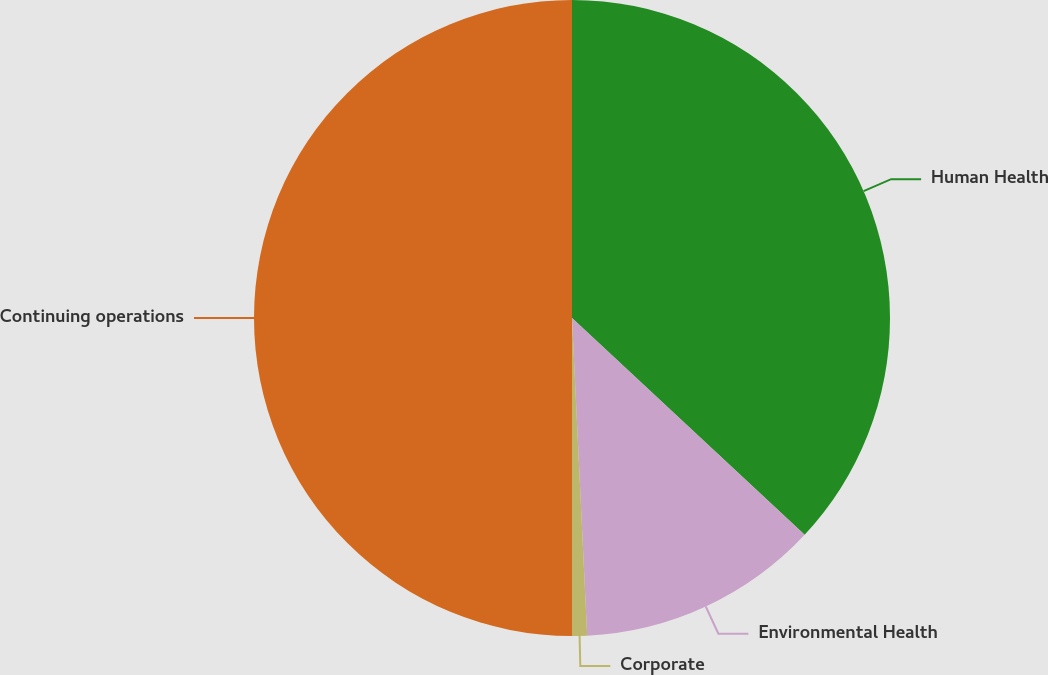<chart> <loc_0><loc_0><loc_500><loc_500><pie_chart><fcel>Human Health<fcel>Environmental Health<fcel>Corporate<fcel>Continuing operations<nl><fcel>36.94%<fcel>12.3%<fcel>0.76%<fcel>50.0%<nl></chart> 